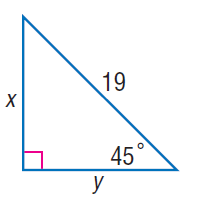Answer the mathemtical geometry problem and directly provide the correct option letter.
Question: Find y.
Choices: A: \frac { 17 \sqrt { 2 } } { 2 } B: \frac { 19 \sqrt { 2 } } { 2 } C: \frac { 21 \sqrt { 2 } } { 2 } D: \frac { 23 \sqrt { 2 } } { 2 } B 